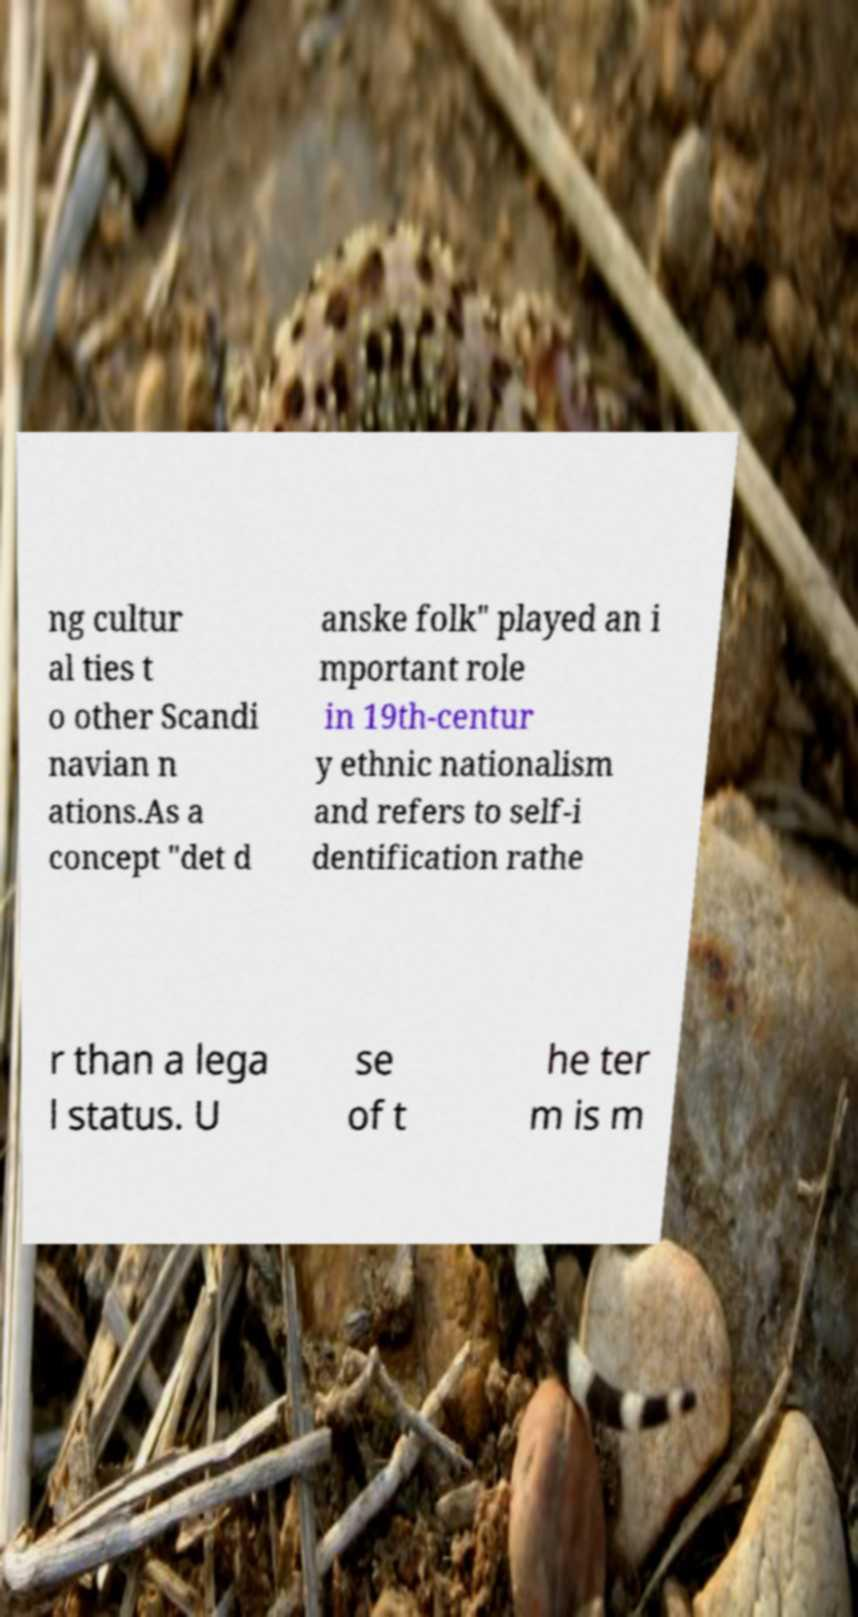For documentation purposes, I need the text within this image transcribed. Could you provide that? ng cultur al ties t o other Scandi navian n ations.As a concept "det d anske folk" played an i mportant role in 19th-centur y ethnic nationalism and refers to self-i dentification rathe r than a lega l status. U se of t he ter m is m 